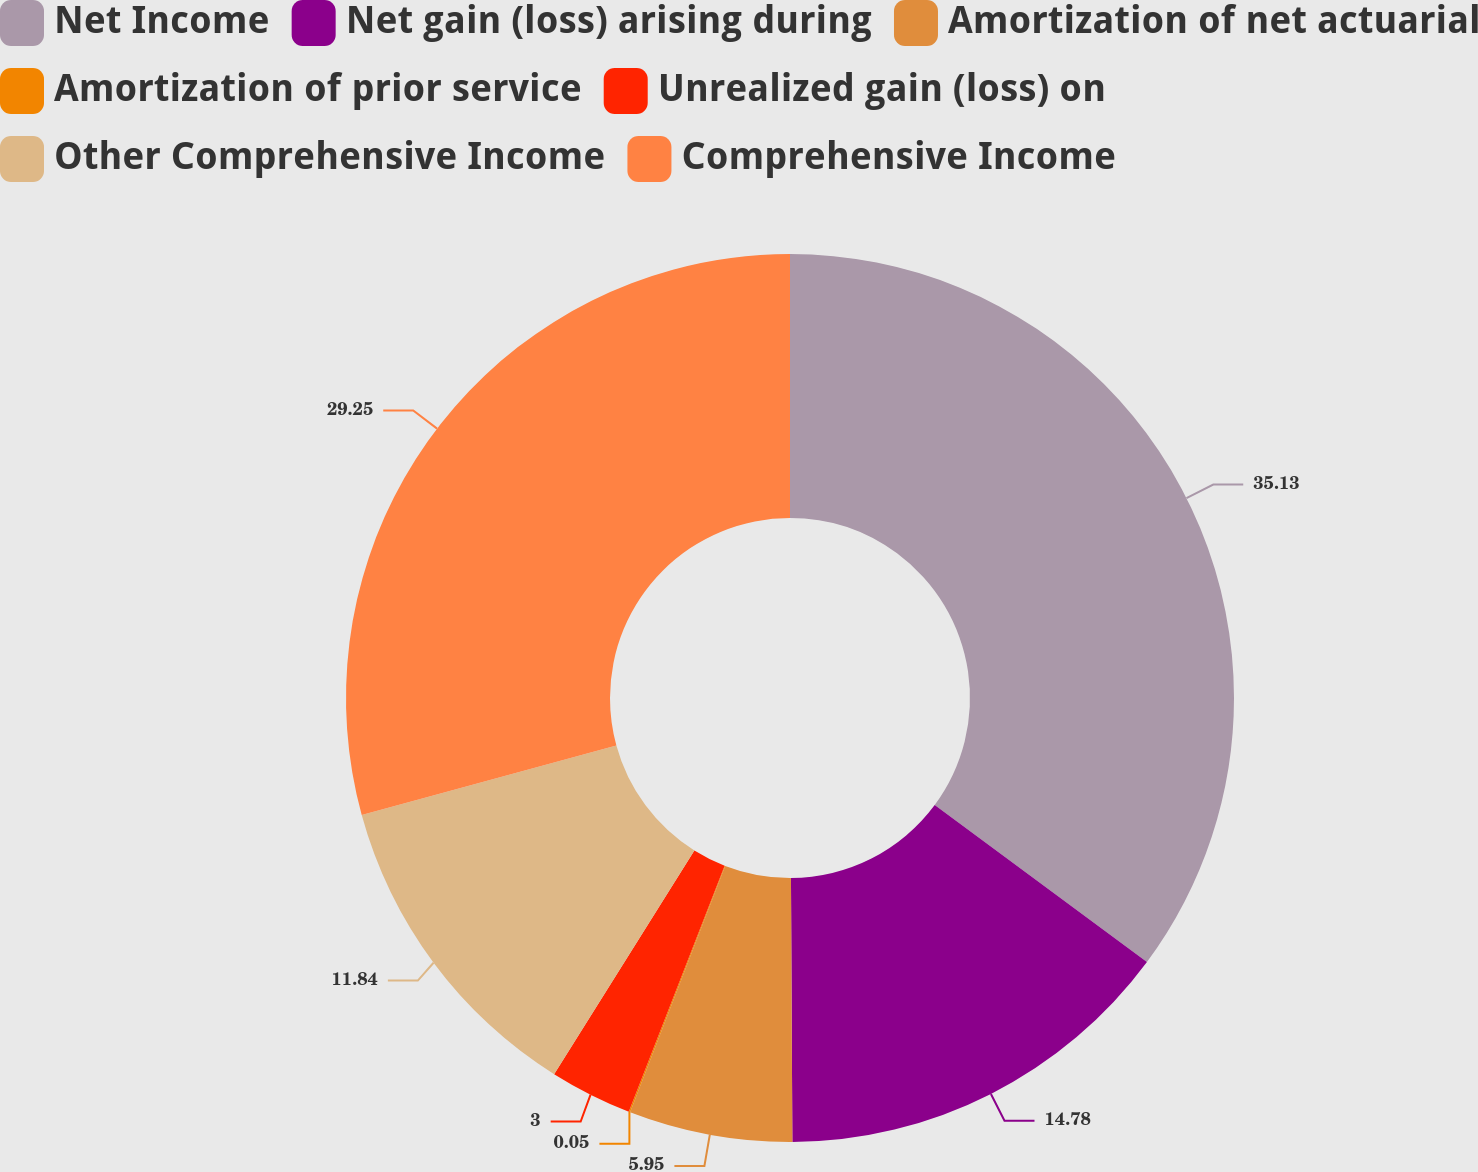Convert chart to OTSL. <chart><loc_0><loc_0><loc_500><loc_500><pie_chart><fcel>Net Income<fcel>Net gain (loss) arising during<fcel>Amortization of net actuarial<fcel>Amortization of prior service<fcel>Unrealized gain (loss) on<fcel>Other Comprehensive Income<fcel>Comprehensive Income<nl><fcel>35.14%<fcel>14.78%<fcel>5.95%<fcel>0.05%<fcel>3.0%<fcel>11.84%<fcel>29.25%<nl></chart> 